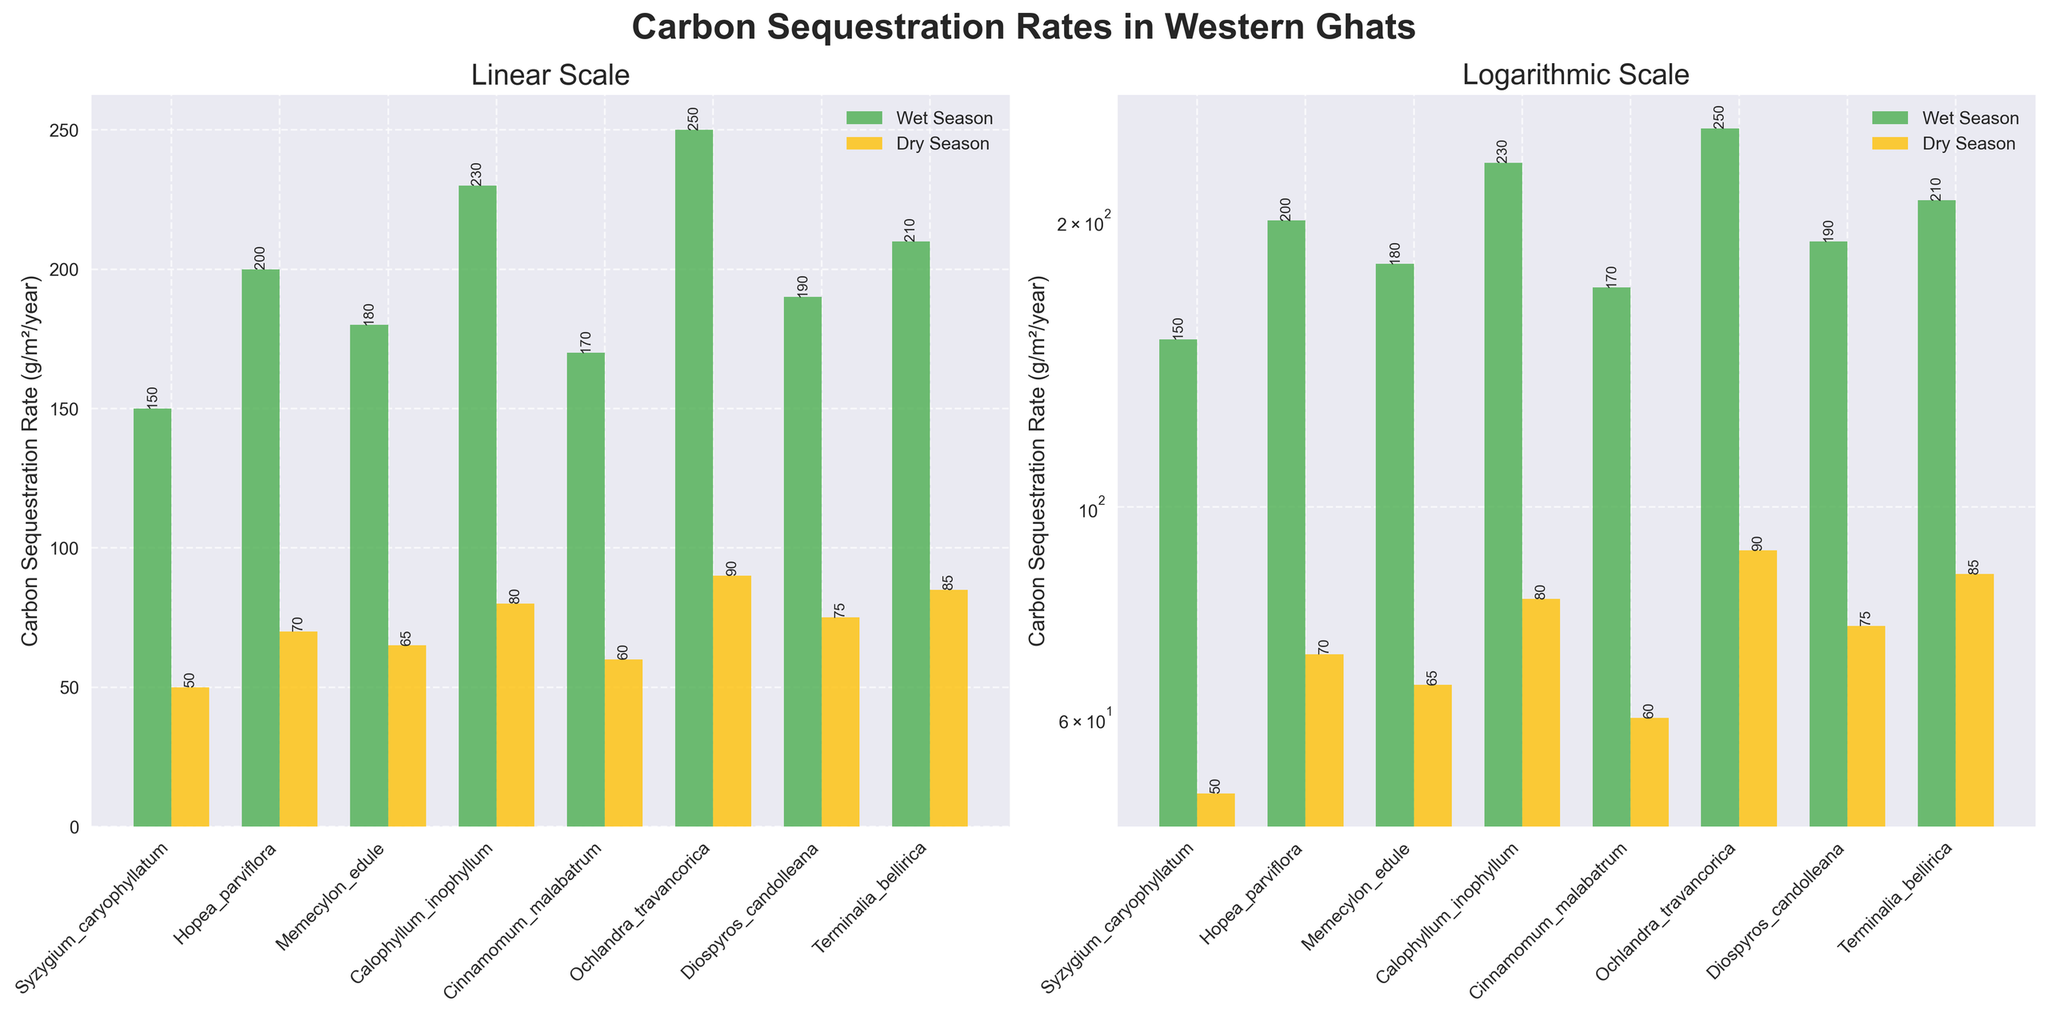What is the title of the figure? The title of the figure can be found at the top and reads "Carbon Sequestration Rates in Western Ghats."
Answer: Carbon Sequestration Rates in Western Ghats How many plant species are plotted in the figure? Count the number of unique plant species labels on the x-axis of either subplot.
Answer: 8 What is the overall trend comparing wet season versus dry season carbon sequestration rates? By observing both subplots, note that carbon sequestration rates are generally higher in the wet season compared to the dry season for all plant species.
Answer: Higher in wet season Which species shows the maximum carbon sequestration rate in the dry season? Look for the highest bar in the dry season (yellow) bars on either subplot.
Answer: Ochlandra_travancorica Which subplot uses a logarithmic scale? Identify the subplot that has "Logarithmic Scale" in its title and observe the logarithmic tick marks on the y-axis.
Answer: The right subplot What is the difference in carbon sequestration rates between the wet season and the dry season for Syzygium caryophyllatum? Locate Syzygium caryophyllatum on the x-axis and subtract the dry season rate from the wet season rate. 150 (wet) - 50 (dry) = 100.
Answer: 100 Which species has the smallest difference in carbon sequestration rates between the wet and dry seasons? For each species, calculate the absolute difference between wet and dry season rates. Identify the species with the smallest difference. Diospyros candolleana: 190 - 75 = 115, Memecylon edule: 180 - 65 = 115, all others have greater differences. It's a tie.
Answer: Memecylon edule and Diospyros candolleana If you had to estimate, by what factor is the carbon sequestration rate higher in the wet season compared to the dry season for Terminalia bellirica? Divide the wet season rate by the dry season rate for Terminalia bellirica. 210 / 85 ≈ 2.47
Answer: ≈ 2.47 What does the horizontal alignment and bar color in the left subplot represent? The horizontal alignment of bars (left or right of center) differentiates wet vs dry season, and the bar colors green and yellow also represent wet and dry seasons respectively.
Answer: Season representation Which species has a carbon sequestration rate of exactly 80 g/m²/year in the dry season? Identify the yellow bar with a height of 80 g/m²/year on either subplot.
Answer: Calophyllum inophyllum 